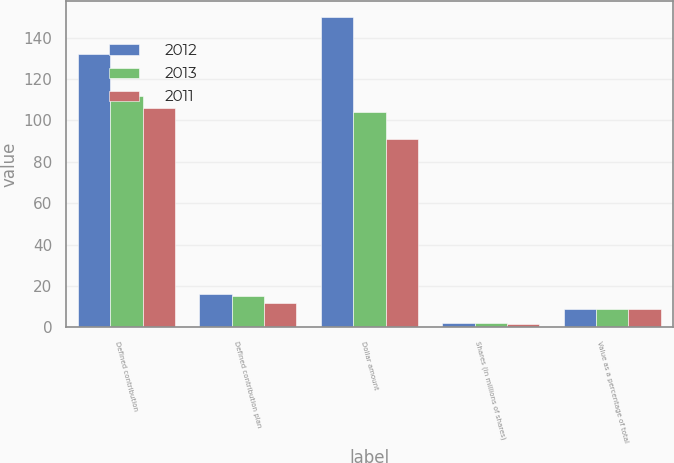Convert chart to OTSL. <chart><loc_0><loc_0><loc_500><loc_500><stacked_bar_chart><ecel><fcel>Defined contribution<fcel>Defined contribution plan<fcel>Dollar amount<fcel>Shares (in millions of shares)<fcel>Value as a percentage of total<nl><fcel>2012<fcel>132<fcel>16<fcel>150<fcel>2<fcel>9<nl><fcel>2013<fcel>112<fcel>15<fcel>104<fcel>1.9<fcel>9<nl><fcel>2011<fcel>106<fcel>12<fcel>91<fcel>1.8<fcel>9<nl></chart> 